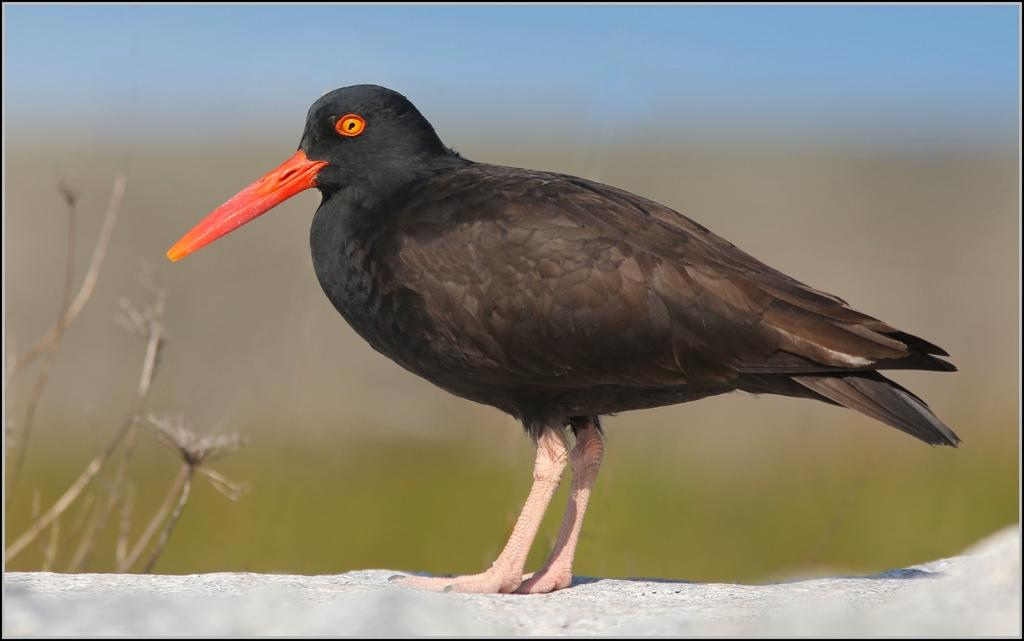What type of bird can be seen in the image? There is a black color bird in the image. Where is the bird located? The bird is on a rock. In which direction is the bird facing? The bird is facing towards the left side. What can be seen on the left side of the image? There is a plant on the left side of the image. How would you describe the background of the image? The background of the image is blurred. Is the bird carrying a watch in the image? There is no watch visible in the image, and the bird is not carrying anything. 